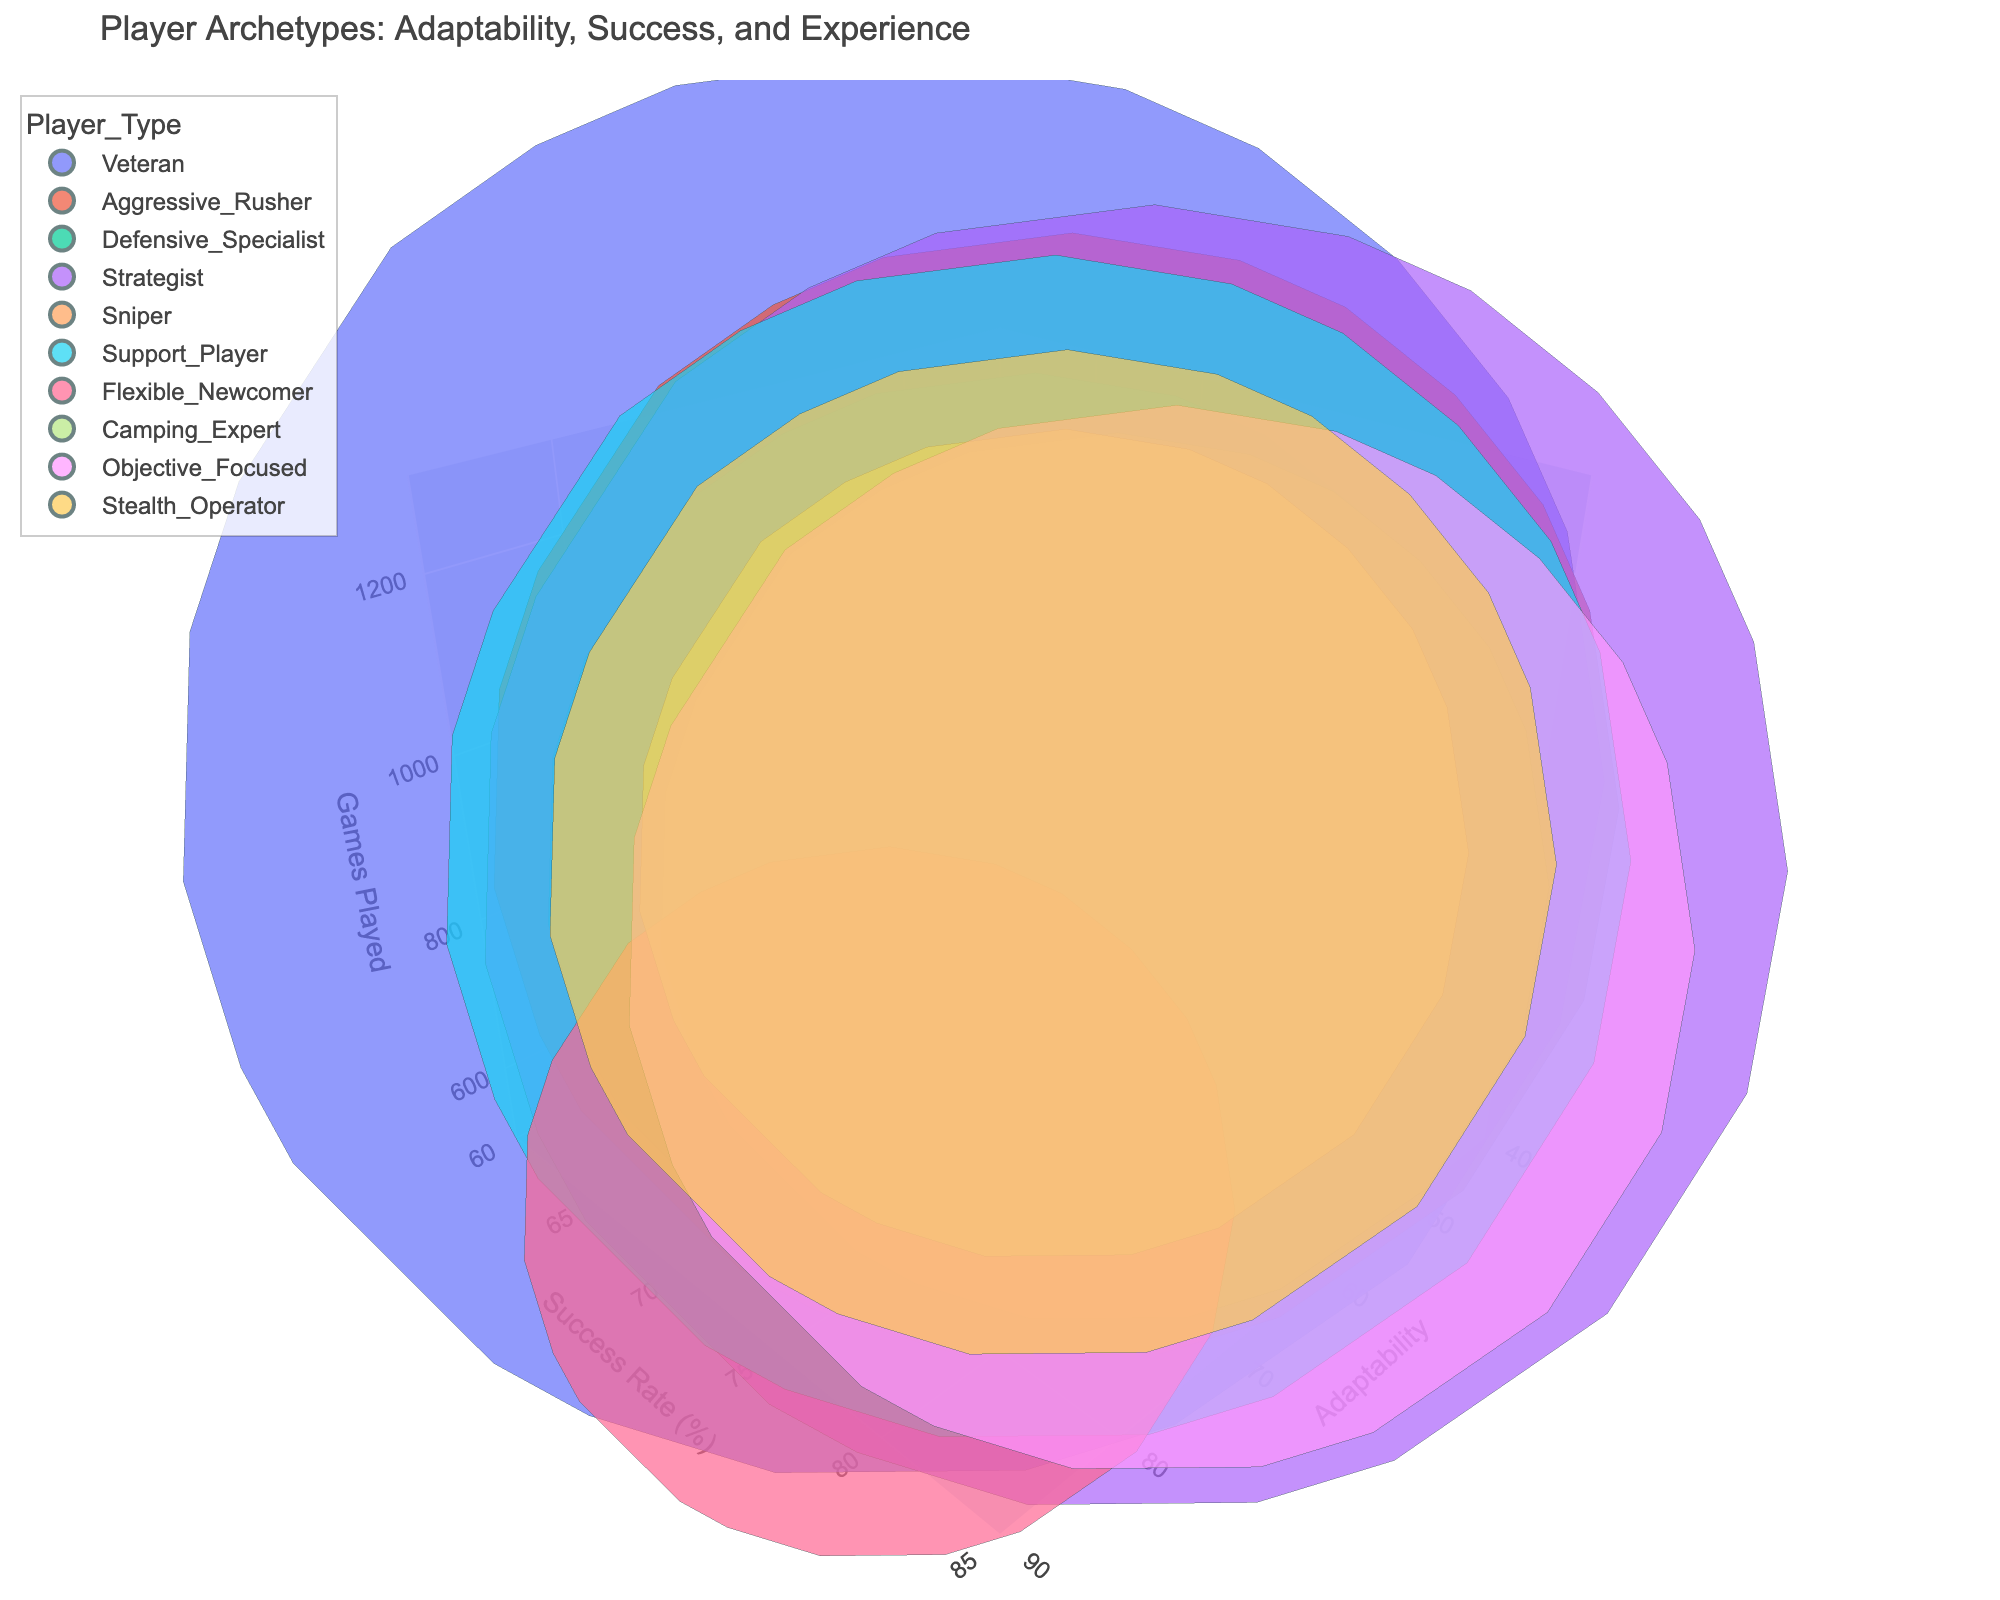What is the title of the figure? The title is displayed at the top of the figure in large, bold text. To find it, simply look at the top of the chart where the name is written.
Answer: Player Archetypes: Adaptability, Success, and Experience How many different player archetypes are there in the chart? Each bubble represents a player archetype and is labeled with its name. Count these labeled points to find the number of different archetypes.
Answer: 10 Which player type has the highest Adaptability Score? Look at the x-axis (Adaptability Score) and identify which bubble is positioned furthest to the right. The label of this bubble indicates the player type.
Answer: Veteran Which player type has the lowest Success Rate? Observe the y-axis (Success Rate) and find the bubble that's positioned lowest. The label on this bubble indicates the player type.
Answer: Camping Expert What is the range of Games Played among the player archetypes? Check the z-axis (Games Played) for the minimum and maximum values visible and subtract the minimum from the maximum to find the range.
Answer: 700 Which player types have played the most and least number of games? Identify the bubbles that are positioned at the upper and lower extremes of the z-axis (Games Played), and check their labels.
Answer: Veteran (most), Flexible Newcomer (least) How do Aggressive Rusher and Strategist compare in terms of Success Rate? Locate the bubbles for Aggressive Rusher and Strategist and compare their positions along the y-axis (Success Rate).
Answer: Strategist has a higher Success Rate than Aggressive Rusher What is the average Adaptability Score for Veteran and Flexible Newcomer? Sum the Adaptability Scores of Veteran (85) and Flexible Newcomer (80) and divide by 2 to get the average.
Answer: 82.5 Which player type has the closest Success Rate to the Objective Focused player? Find the bubble for Objective Focused and check the Success Rate. Then, look for the bubble with a Success Rate nearest to this value and note its label.
Answer: Veteran 